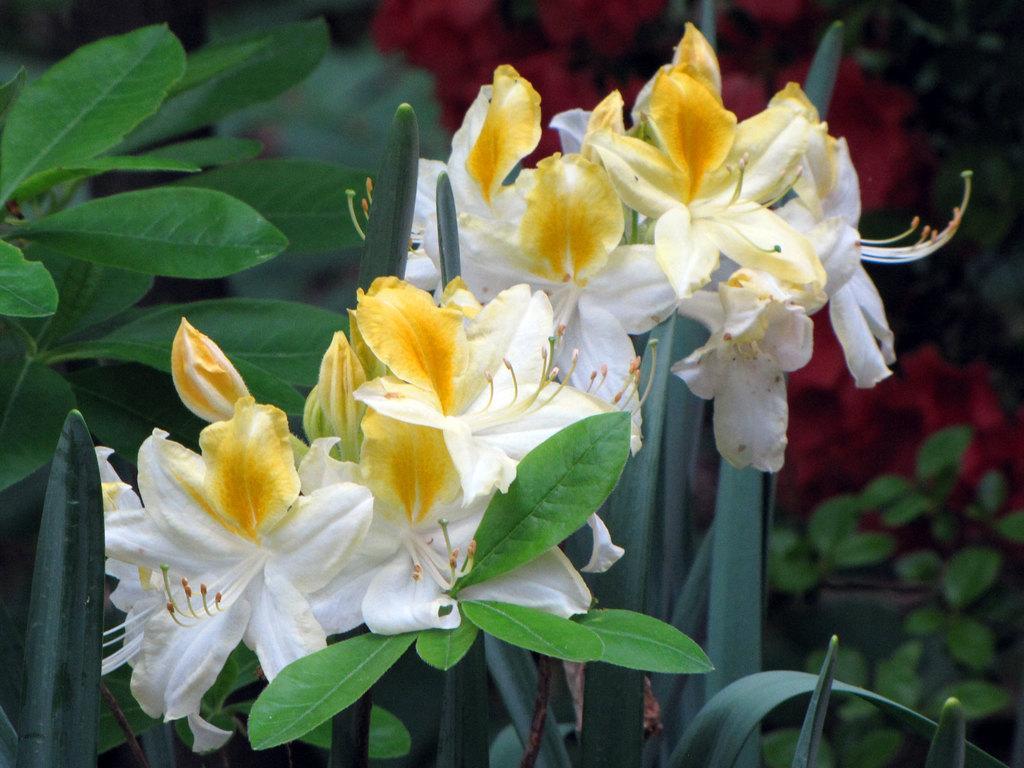In one or two sentences, can you explain what this image depicts? In this picture, in the middle, we can see a plant with some flowers. On the right side, we can see some plants. On the left side, we can also see some green leaves. In the background, we can see red color flowers. 